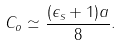Convert formula to latex. <formula><loc_0><loc_0><loc_500><loc_500>C _ { o } \simeq \frac { ( \epsilon _ { s } + 1 ) a } { 8 } .</formula> 